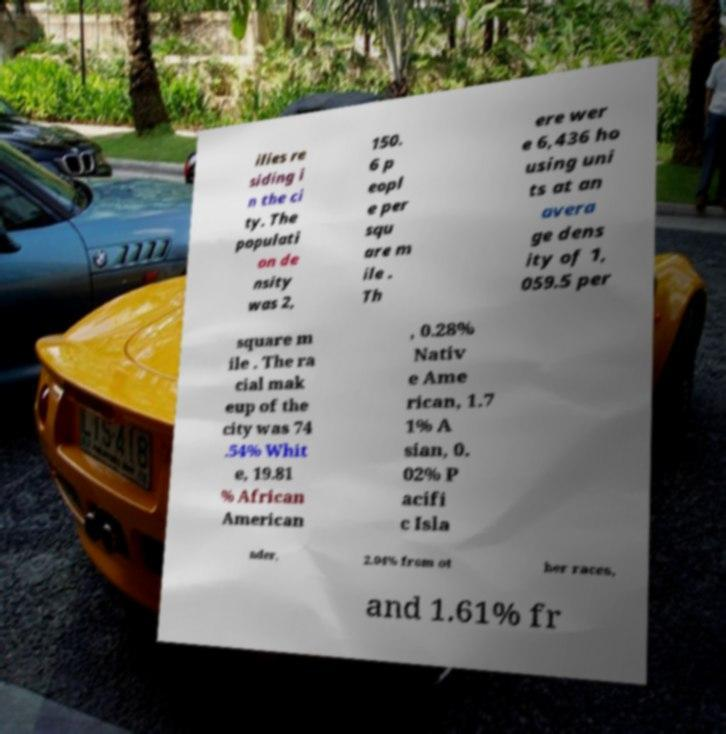Please identify and transcribe the text found in this image. ilies re siding i n the ci ty. The populati on de nsity was 2, 150. 6 p eopl e per squ are m ile . Th ere wer e 6,436 ho using uni ts at an avera ge dens ity of 1, 059.5 per square m ile . The ra cial mak eup of the city was 74 .54% Whit e, 19.81 % African American , 0.28% Nativ e Ame rican, 1.7 1% A sian, 0. 02% P acifi c Isla nder, 2.04% from ot her races, and 1.61% fr 